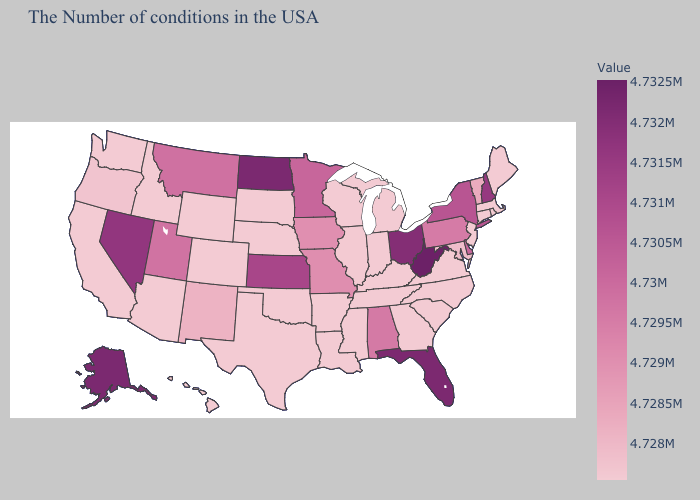Which states hav the highest value in the South?
Answer briefly. West Virginia. Among the states that border Pennsylvania , does West Virginia have the lowest value?
Short answer required. No. Which states have the highest value in the USA?
Quick response, please. West Virginia. Among the states that border Nevada , does Idaho have the highest value?
Keep it brief. No. Does West Virginia have the highest value in the USA?
Be succinct. Yes. 